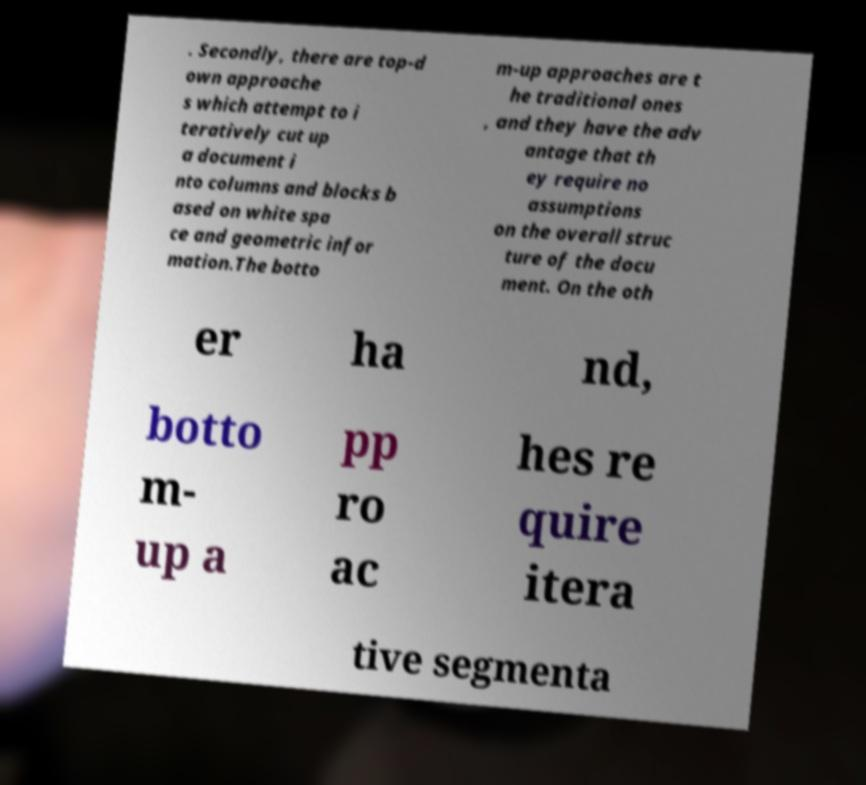Please read and relay the text visible in this image. What does it say? . Secondly, there are top-d own approache s which attempt to i teratively cut up a document i nto columns and blocks b ased on white spa ce and geometric infor mation.The botto m-up approaches are t he traditional ones , and they have the adv antage that th ey require no assumptions on the overall struc ture of the docu ment. On the oth er ha nd, botto m- up a pp ro ac hes re quire itera tive segmenta 